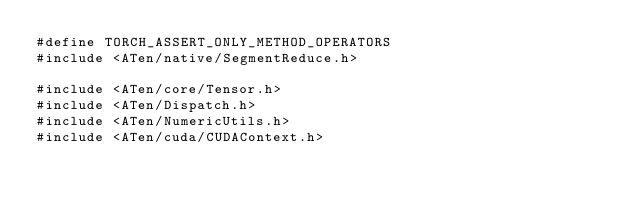<code> <loc_0><loc_0><loc_500><loc_500><_Cuda_>#define TORCH_ASSERT_ONLY_METHOD_OPERATORS
#include <ATen/native/SegmentReduce.h>

#include <ATen/core/Tensor.h>
#include <ATen/Dispatch.h>
#include <ATen/NumericUtils.h>
#include <ATen/cuda/CUDAContext.h></code> 